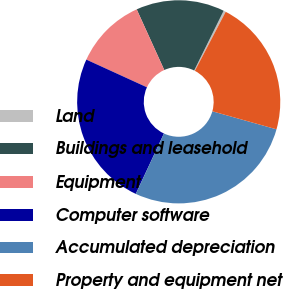Convert chart to OTSL. <chart><loc_0><loc_0><loc_500><loc_500><pie_chart><fcel>Land<fcel>Buildings and leasehold<fcel>Equipment<fcel>Computer software<fcel>Accumulated depreciation<fcel>Property and equipment net<nl><fcel>0.36%<fcel>14.08%<fcel>11.39%<fcel>24.88%<fcel>27.58%<fcel>21.71%<nl></chart> 